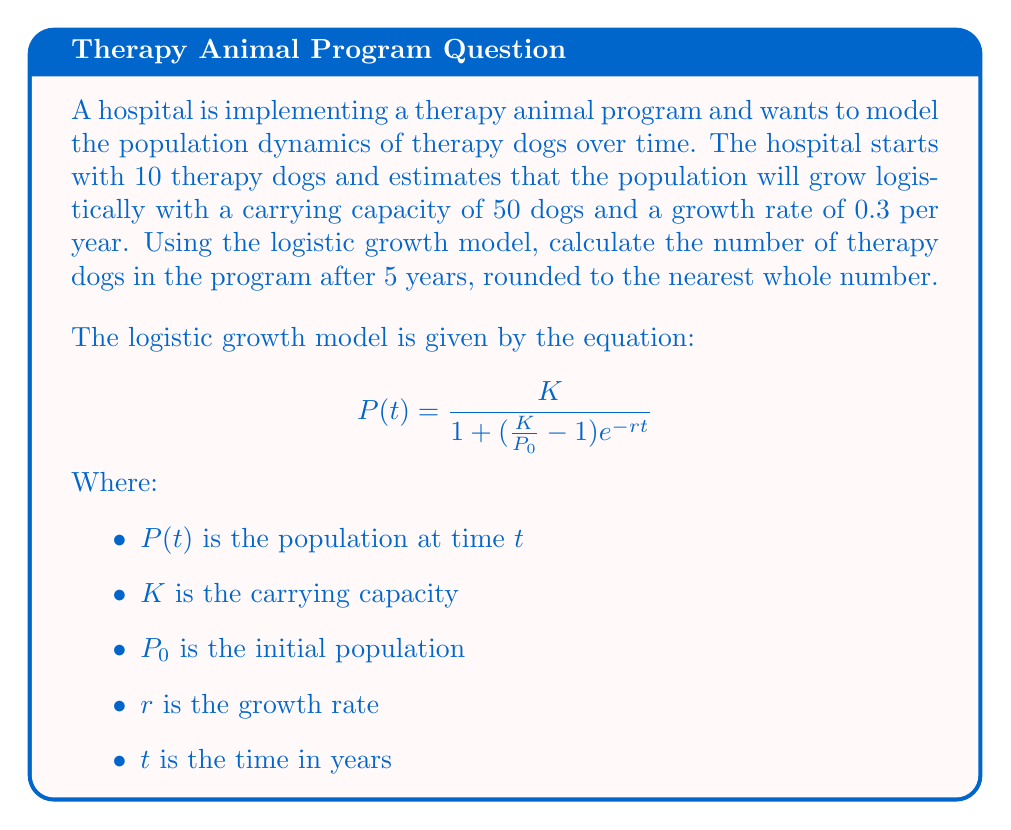Can you answer this question? To solve this problem, we'll use the logistic growth model equation and plug in the given values:

$K = 50$ (carrying capacity)
$P_0 = 10$ (initial population)
$r = 0.3$ (growth rate)
$t = 5$ (time in years)

Let's substitute these values into the equation:

$$P(5) = \frac{50}{1 + (\frac{50}{10} - 1)e^{-0.3(5)}}$$

Now, let's solve this step-by-step:

1. Simplify the fraction inside the parentheses:
   $$P(5) = \frac{50}{1 + (5 - 1)e^{-1.5}}$$

2. Simplify further:
   $$P(5) = \frac{50}{1 + 4e^{-1.5}}$$

3. Calculate $e^{-1.5}$:
   $e^{-1.5} \approx 0.2231$

4. Multiply:
   $$P(5) = \frac{50}{1 + 4(0.2231)} = \frac{50}{1 + 0.8924}$$

5. Add in the denominator:
   $$P(5) = \frac{50}{1.8924}$$

6. Divide:
   $$P(5) \approx 26.4214$$

7. Round to the nearest whole number:
   $$P(5) \approx 26$$

Therefore, after 5 years, there will be approximately 26 therapy dogs in the program.
Answer: 26 therapy dogs 